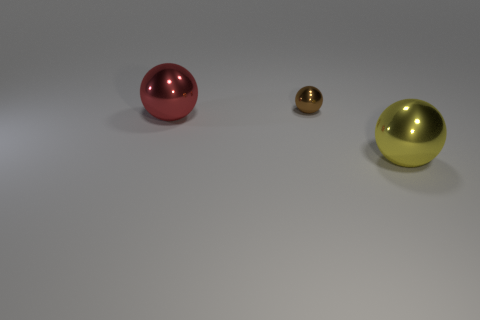There is a large metal thing behind the big sphere to the right of the red metallic thing; how many large red spheres are to the right of it?
Offer a terse response. 0. Is there a matte ball that has the same color as the small object?
Your answer should be compact. No. There is a metal ball that is the same size as the yellow thing; what is its color?
Give a very brief answer. Red. Is there a brown metallic object that has the same shape as the big red metallic object?
Give a very brief answer. Yes. Are there any big objects that are in front of the large shiny ball that is behind the large metal thing in front of the big red sphere?
Give a very brief answer. Yes. There is a yellow metallic thing that is the same size as the red metal object; what shape is it?
Make the answer very short. Sphere. What color is the other big metal object that is the same shape as the red thing?
Keep it short and to the point. Yellow. How many objects are purple spheres or big yellow balls?
Ensure brevity in your answer.  1. There is a big metallic object that is in front of the red sphere; is its shape the same as the big metal object left of the small brown metal thing?
Your answer should be compact. Yes. There is a big shiny thing that is to the left of the brown sphere; what shape is it?
Your response must be concise. Sphere. 